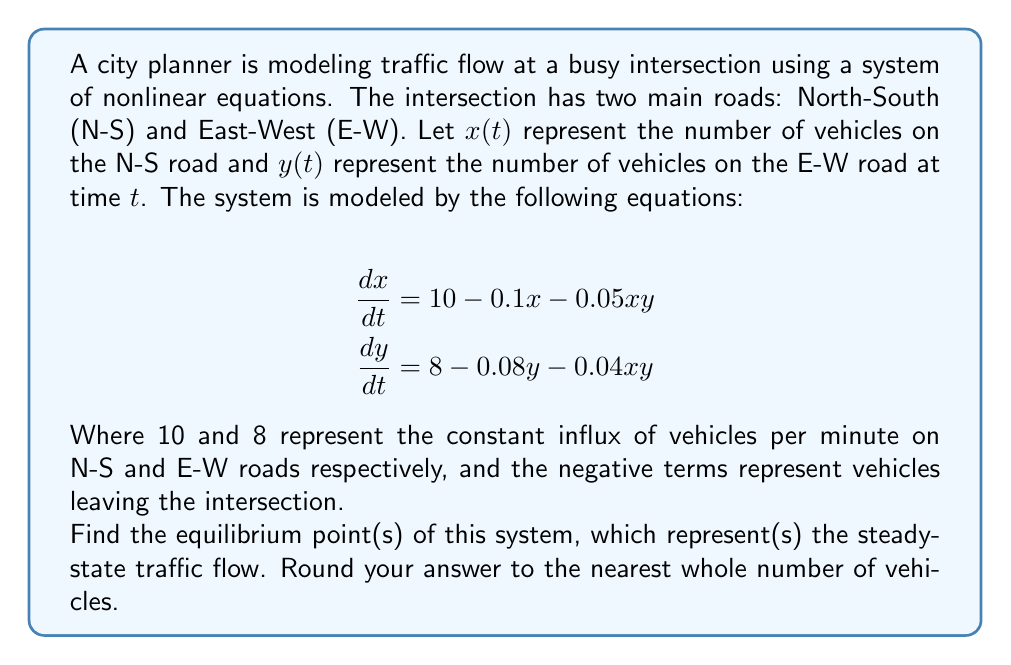Give your solution to this math problem. To find the equilibrium point(s), we need to set both derivatives equal to zero and solve the resulting system of equations:

1) Set $\frac{dx}{dt} = 0$ and $\frac{dy}{dt} = 0$:

   $$0 = 10 - 0.1x - 0.05xy$$
   $$0 = 8 - 0.08y - 0.04xy$$

2) From the first equation:

   $$0.1x + 0.05xy = 10$$
   $$x(0.1 + 0.05y) = 10$$
   $$x = \frac{10}{0.1 + 0.05y}$$

3) Substitute this into the second equation:

   $$0 = 8 - 0.08y - 0.04y(\frac{10}{0.1 + 0.05y})$$

4) Multiply both sides by $(0.1 + 0.05y)$:

   $$0 = 8(0.1 + 0.05y) - 0.08y(0.1 + 0.05y) - 0.4y$$

5) Expand:

   $$0 = 0.8 + 0.4y - 0.008y - 0.004y^2 - 0.4y$$
   $$0 = 0.8 - 0.008y - 0.004y^2$$

6) Multiply by 1000 to eliminate decimals:

   $$0 = 800 - 8y - 4y^2$$

7) Solve this quadratic equation:

   $$4y^2 + 8y - 800 = 0$$
   $$y = \frac{-8 \pm \sqrt{8^2 + 4(4)(800)}}{2(4)}$$
   $$y \approx 13.8 \text{ or } y \approx -14.8$$

8) Since y represents the number of vehicles, it must be positive. So y ≈ 13.8

9) Substitute this back into the equation for x:

   $$x = \frac{10}{0.1 + 0.05(13.8)} \approx 27.0$$

10) Rounding to the nearest whole number:

    x ≈ 27 and y ≈ 14
Answer: (27, 14) 